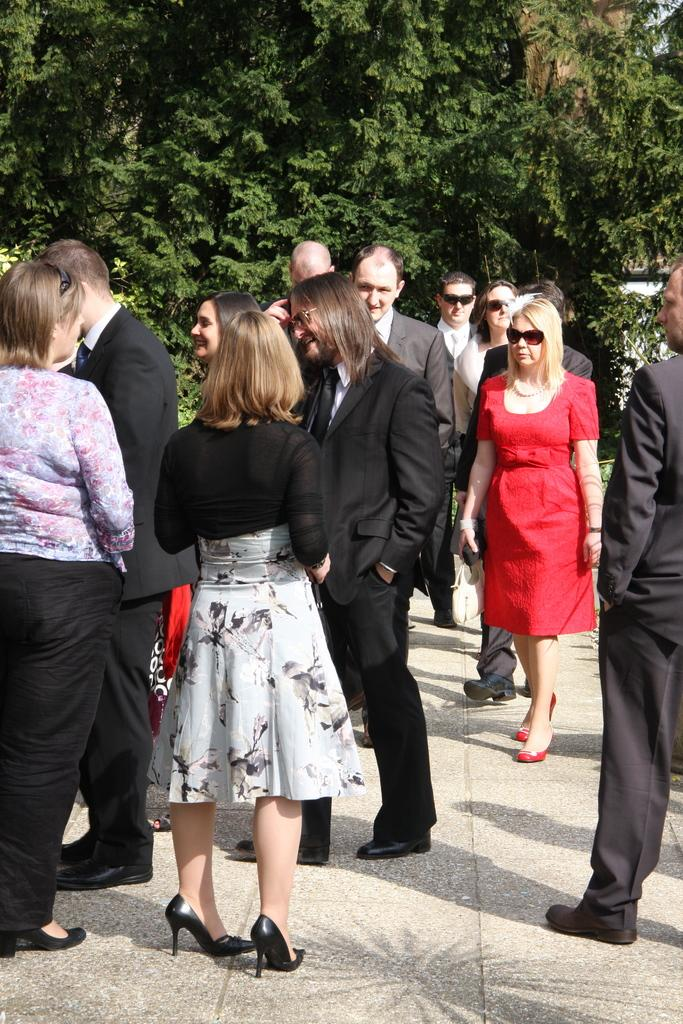What is happening in the image? There are persons standing on the floor in the image. What can be seen in the background of the image? There are trees visible in the background of the image. What type of berry is being discussed by the committee in the image? There is no committee or berry present in the image; it only features persons standing on the floor and trees in the background. 